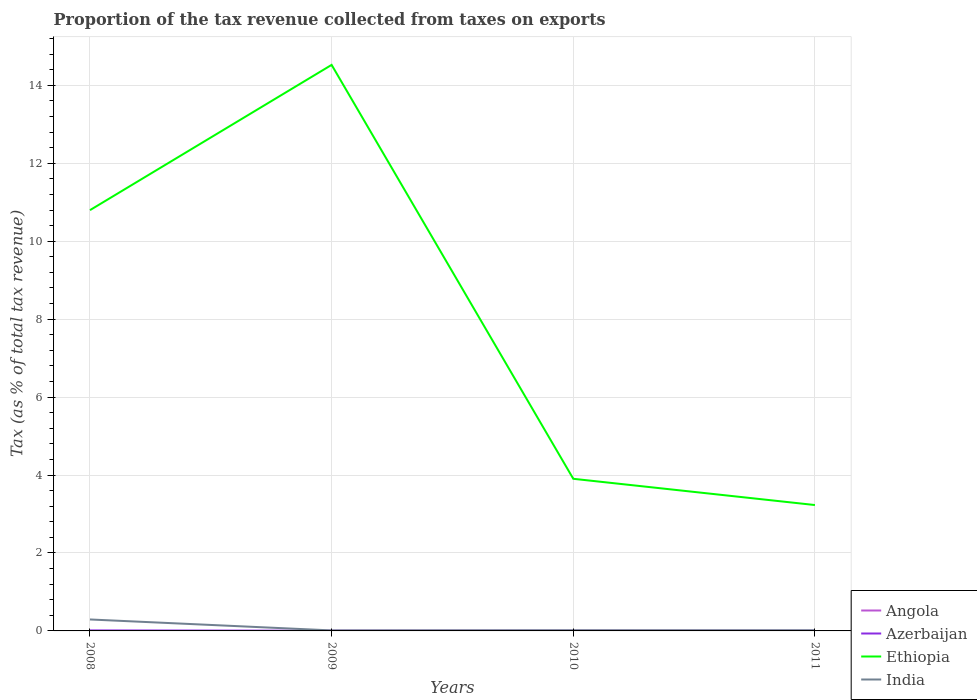Is the number of lines equal to the number of legend labels?
Your response must be concise. Yes. Across all years, what is the maximum proportion of the tax revenue collected in Azerbaijan?
Offer a very short reply. 0. In which year was the proportion of the tax revenue collected in India maximum?
Offer a terse response. 2009. What is the total proportion of the tax revenue collected in Azerbaijan in the graph?
Give a very brief answer. 0.01. What is the difference between the highest and the second highest proportion of the tax revenue collected in Azerbaijan?
Ensure brevity in your answer.  0.01. Is the proportion of the tax revenue collected in India strictly greater than the proportion of the tax revenue collected in Angola over the years?
Provide a short and direct response. No. Does the graph contain grids?
Offer a terse response. Yes. Where does the legend appear in the graph?
Offer a terse response. Bottom right. How many legend labels are there?
Make the answer very short. 4. How are the legend labels stacked?
Provide a short and direct response. Vertical. What is the title of the graph?
Keep it short and to the point. Proportion of the tax revenue collected from taxes on exports. Does "Morocco" appear as one of the legend labels in the graph?
Your answer should be very brief. No. What is the label or title of the X-axis?
Provide a succinct answer. Years. What is the label or title of the Y-axis?
Offer a very short reply. Tax (as % of total tax revenue). What is the Tax (as % of total tax revenue) of Angola in 2008?
Your response must be concise. 0. What is the Tax (as % of total tax revenue) in Azerbaijan in 2008?
Keep it short and to the point. 0.01. What is the Tax (as % of total tax revenue) of Ethiopia in 2008?
Keep it short and to the point. 10.8. What is the Tax (as % of total tax revenue) of India in 2008?
Offer a very short reply. 0.29. What is the Tax (as % of total tax revenue) of Angola in 2009?
Provide a succinct answer. 0. What is the Tax (as % of total tax revenue) in Azerbaijan in 2009?
Keep it short and to the point. 0. What is the Tax (as % of total tax revenue) in Ethiopia in 2009?
Your answer should be compact. 14.53. What is the Tax (as % of total tax revenue) of India in 2009?
Your answer should be very brief. 0.01. What is the Tax (as % of total tax revenue) in Angola in 2010?
Offer a terse response. 0. What is the Tax (as % of total tax revenue) of Azerbaijan in 2010?
Your answer should be compact. 0. What is the Tax (as % of total tax revenue) of Ethiopia in 2010?
Your response must be concise. 3.9. What is the Tax (as % of total tax revenue) of India in 2010?
Your answer should be very brief. 0.02. What is the Tax (as % of total tax revenue) of Angola in 2011?
Provide a succinct answer. 0. What is the Tax (as % of total tax revenue) of Azerbaijan in 2011?
Your response must be concise. 0. What is the Tax (as % of total tax revenue) in Ethiopia in 2011?
Your answer should be compact. 3.23. What is the Tax (as % of total tax revenue) of India in 2011?
Give a very brief answer. 0.02. Across all years, what is the maximum Tax (as % of total tax revenue) of Angola?
Ensure brevity in your answer.  0. Across all years, what is the maximum Tax (as % of total tax revenue) in Azerbaijan?
Ensure brevity in your answer.  0.01. Across all years, what is the maximum Tax (as % of total tax revenue) in Ethiopia?
Make the answer very short. 14.53. Across all years, what is the maximum Tax (as % of total tax revenue) of India?
Your response must be concise. 0.29. Across all years, what is the minimum Tax (as % of total tax revenue) in Angola?
Provide a succinct answer. 0. Across all years, what is the minimum Tax (as % of total tax revenue) in Azerbaijan?
Your answer should be very brief. 0. Across all years, what is the minimum Tax (as % of total tax revenue) of Ethiopia?
Offer a very short reply. 3.23. Across all years, what is the minimum Tax (as % of total tax revenue) of India?
Make the answer very short. 0.01. What is the total Tax (as % of total tax revenue) in Angola in the graph?
Make the answer very short. 0. What is the total Tax (as % of total tax revenue) in Azerbaijan in the graph?
Give a very brief answer. 0.02. What is the total Tax (as % of total tax revenue) of Ethiopia in the graph?
Make the answer very short. 32.46. What is the total Tax (as % of total tax revenue) of India in the graph?
Make the answer very short. 0.34. What is the difference between the Tax (as % of total tax revenue) of Angola in 2008 and that in 2009?
Make the answer very short. -0. What is the difference between the Tax (as % of total tax revenue) of Azerbaijan in 2008 and that in 2009?
Your answer should be very brief. 0.01. What is the difference between the Tax (as % of total tax revenue) in Ethiopia in 2008 and that in 2009?
Provide a short and direct response. -3.73. What is the difference between the Tax (as % of total tax revenue) in India in 2008 and that in 2009?
Provide a succinct answer. 0.28. What is the difference between the Tax (as % of total tax revenue) in Angola in 2008 and that in 2010?
Keep it short and to the point. -0. What is the difference between the Tax (as % of total tax revenue) of Azerbaijan in 2008 and that in 2010?
Give a very brief answer. 0.01. What is the difference between the Tax (as % of total tax revenue) in Ethiopia in 2008 and that in 2010?
Make the answer very short. 6.89. What is the difference between the Tax (as % of total tax revenue) of India in 2008 and that in 2010?
Your answer should be very brief. 0.28. What is the difference between the Tax (as % of total tax revenue) of Angola in 2008 and that in 2011?
Offer a terse response. -0. What is the difference between the Tax (as % of total tax revenue) in Azerbaijan in 2008 and that in 2011?
Offer a very short reply. 0.01. What is the difference between the Tax (as % of total tax revenue) of Ethiopia in 2008 and that in 2011?
Offer a terse response. 7.57. What is the difference between the Tax (as % of total tax revenue) of India in 2008 and that in 2011?
Your answer should be compact. 0.28. What is the difference between the Tax (as % of total tax revenue) of Angola in 2009 and that in 2010?
Your answer should be very brief. -0. What is the difference between the Tax (as % of total tax revenue) of Ethiopia in 2009 and that in 2010?
Provide a succinct answer. 10.62. What is the difference between the Tax (as % of total tax revenue) in India in 2009 and that in 2010?
Make the answer very short. -0. What is the difference between the Tax (as % of total tax revenue) of Azerbaijan in 2009 and that in 2011?
Provide a short and direct response. 0. What is the difference between the Tax (as % of total tax revenue) of Ethiopia in 2009 and that in 2011?
Your answer should be compact. 11.3. What is the difference between the Tax (as % of total tax revenue) of India in 2009 and that in 2011?
Offer a very short reply. -0. What is the difference between the Tax (as % of total tax revenue) of Angola in 2010 and that in 2011?
Keep it short and to the point. 0. What is the difference between the Tax (as % of total tax revenue) in Azerbaijan in 2010 and that in 2011?
Offer a terse response. 0. What is the difference between the Tax (as % of total tax revenue) in Ethiopia in 2010 and that in 2011?
Provide a short and direct response. 0.67. What is the difference between the Tax (as % of total tax revenue) of India in 2010 and that in 2011?
Provide a succinct answer. 0. What is the difference between the Tax (as % of total tax revenue) in Angola in 2008 and the Tax (as % of total tax revenue) in Azerbaijan in 2009?
Offer a very short reply. -0. What is the difference between the Tax (as % of total tax revenue) in Angola in 2008 and the Tax (as % of total tax revenue) in Ethiopia in 2009?
Give a very brief answer. -14.53. What is the difference between the Tax (as % of total tax revenue) in Angola in 2008 and the Tax (as % of total tax revenue) in India in 2009?
Your answer should be very brief. -0.01. What is the difference between the Tax (as % of total tax revenue) of Azerbaijan in 2008 and the Tax (as % of total tax revenue) of Ethiopia in 2009?
Offer a terse response. -14.51. What is the difference between the Tax (as % of total tax revenue) in Azerbaijan in 2008 and the Tax (as % of total tax revenue) in India in 2009?
Make the answer very short. -0. What is the difference between the Tax (as % of total tax revenue) in Ethiopia in 2008 and the Tax (as % of total tax revenue) in India in 2009?
Keep it short and to the point. 10.78. What is the difference between the Tax (as % of total tax revenue) in Angola in 2008 and the Tax (as % of total tax revenue) in Azerbaijan in 2010?
Your response must be concise. -0. What is the difference between the Tax (as % of total tax revenue) in Angola in 2008 and the Tax (as % of total tax revenue) in Ethiopia in 2010?
Ensure brevity in your answer.  -3.9. What is the difference between the Tax (as % of total tax revenue) in Angola in 2008 and the Tax (as % of total tax revenue) in India in 2010?
Your answer should be compact. -0.02. What is the difference between the Tax (as % of total tax revenue) in Azerbaijan in 2008 and the Tax (as % of total tax revenue) in Ethiopia in 2010?
Make the answer very short. -3.89. What is the difference between the Tax (as % of total tax revenue) in Azerbaijan in 2008 and the Tax (as % of total tax revenue) in India in 2010?
Your response must be concise. -0. What is the difference between the Tax (as % of total tax revenue) in Ethiopia in 2008 and the Tax (as % of total tax revenue) in India in 2010?
Your answer should be compact. 10.78. What is the difference between the Tax (as % of total tax revenue) in Angola in 2008 and the Tax (as % of total tax revenue) in Azerbaijan in 2011?
Provide a succinct answer. -0. What is the difference between the Tax (as % of total tax revenue) in Angola in 2008 and the Tax (as % of total tax revenue) in Ethiopia in 2011?
Your answer should be very brief. -3.23. What is the difference between the Tax (as % of total tax revenue) in Angola in 2008 and the Tax (as % of total tax revenue) in India in 2011?
Offer a terse response. -0.02. What is the difference between the Tax (as % of total tax revenue) in Azerbaijan in 2008 and the Tax (as % of total tax revenue) in Ethiopia in 2011?
Offer a terse response. -3.22. What is the difference between the Tax (as % of total tax revenue) in Azerbaijan in 2008 and the Tax (as % of total tax revenue) in India in 2011?
Your answer should be compact. -0. What is the difference between the Tax (as % of total tax revenue) in Ethiopia in 2008 and the Tax (as % of total tax revenue) in India in 2011?
Your answer should be very brief. 10.78. What is the difference between the Tax (as % of total tax revenue) in Angola in 2009 and the Tax (as % of total tax revenue) in Azerbaijan in 2010?
Give a very brief answer. -0. What is the difference between the Tax (as % of total tax revenue) in Angola in 2009 and the Tax (as % of total tax revenue) in Ethiopia in 2010?
Make the answer very short. -3.9. What is the difference between the Tax (as % of total tax revenue) of Angola in 2009 and the Tax (as % of total tax revenue) of India in 2010?
Keep it short and to the point. -0.02. What is the difference between the Tax (as % of total tax revenue) of Azerbaijan in 2009 and the Tax (as % of total tax revenue) of Ethiopia in 2010?
Make the answer very short. -3.9. What is the difference between the Tax (as % of total tax revenue) of Azerbaijan in 2009 and the Tax (as % of total tax revenue) of India in 2010?
Give a very brief answer. -0.01. What is the difference between the Tax (as % of total tax revenue) of Ethiopia in 2009 and the Tax (as % of total tax revenue) of India in 2010?
Keep it short and to the point. 14.51. What is the difference between the Tax (as % of total tax revenue) in Angola in 2009 and the Tax (as % of total tax revenue) in Azerbaijan in 2011?
Provide a succinct answer. -0. What is the difference between the Tax (as % of total tax revenue) in Angola in 2009 and the Tax (as % of total tax revenue) in Ethiopia in 2011?
Provide a short and direct response. -3.23. What is the difference between the Tax (as % of total tax revenue) of Angola in 2009 and the Tax (as % of total tax revenue) of India in 2011?
Provide a succinct answer. -0.02. What is the difference between the Tax (as % of total tax revenue) in Azerbaijan in 2009 and the Tax (as % of total tax revenue) in Ethiopia in 2011?
Your answer should be compact. -3.23. What is the difference between the Tax (as % of total tax revenue) in Azerbaijan in 2009 and the Tax (as % of total tax revenue) in India in 2011?
Your answer should be compact. -0.01. What is the difference between the Tax (as % of total tax revenue) in Ethiopia in 2009 and the Tax (as % of total tax revenue) in India in 2011?
Your answer should be compact. 14.51. What is the difference between the Tax (as % of total tax revenue) in Angola in 2010 and the Tax (as % of total tax revenue) in Azerbaijan in 2011?
Offer a terse response. -0. What is the difference between the Tax (as % of total tax revenue) in Angola in 2010 and the Tax (as % of total tax revenue) in Ethiopia in 2011?
Offer a terse response. -3.23. What is the difference between the Tax (as % of total tax revenue) of Angola in 2010 and the Tax (as % of total tax revenue) of India in 2011?
Your response must be concise. -0.02. What is the difference between the Tax (as % of total tax revenue) in Azerbaijan in 2010 and the Tax (as % of total tax revenue) in Ethiopia in 2011?
Your response must be concise. -3.23. What is the difference between the Tax (as % of total tax revenue) of Azerbaijan in 2010 and the Tax (as % of total tax revenue) of India in 2011?
Your answer should be compact. -0.01. What is the difference between the Tax (as % of total tax revenue) of Ethiopia in 2010 and the Tax (as % of total tax revenue) of India in 2011?
Give a very brief answer. 3.89. What is the average Tax (as % of total tax revenue) of Angola per year?
Provide a succinct answer. 0. What is the average Tax (as % of total tax revenue) of Azerbaijan per year?
Ensure brevity in your answer.  0.01. What is the average Tax (as % of total tax revenue) in Ethiopia per year?
Provide a succinct answer. 8.11. What is the average Tax (as % of total tax revenue) in India per year?
Keep it short and to the point. 0.09. In the year 2008, what is the difference between the Tax (as % of total tax revenue) of Angola and Tax (as % of total tax revenue) of Azerbaijan?
Offer a very short reply. -0.01. In the year 2008, what is the difference between the Tax (as % of total tax revenue) of Angola and Tax (as % of total tax revenue) of Ethiopia?
Provide a succinct answer. -10.8. In the year 2008, what is the difference between the Tax (as % of total tax revenue) in Angola and Tax (as % of total tax revenue) in India?
Your answer should be very brief. -0.29. In the year 2008, what is the difference between the Tax (as % of total tax revenue) of Azerbaijan and Tax (as % of total tax revenue) of Ethiopia?
Ensure brevity in your answer.  -10.79. In the year 2008, what is the difference between the Tax (as % of total tax revenue) of Azerbaijan and Tax (as % of total tax revenue) of India?
Your response must be concise. -0.28. In the year 2008, what is the difference between the Tax (as % of total tax revenue) of Ethiopia and Tax (as % of total tax revenue) of India?
Offer a terse response. 10.5. In the year 2009, what is the difference between the Tax (as % of total tax revenue) of Angola and Tax (as % of total tax revenue) of Azerbaijan?
Offer a terse response. -0. In the year 2009, what is the difference between the Tax (as % of total tax revenue) in Angola and Tax (as % of total tax revenue) in Ethiopia?
Your response must be concise. -14.53. In the year 2009, what is the difference between the Tax (as % of total tax revenue) in Angola and Tax (as % of total tax revenue) in India?
Give a very brief answer. -0.01. In the year 2009, what is the difference between the Tax (as % of total tax revenue) in Azerbaijan and Tax (as % of total tax revenue) in Ethiopia?
Offer a very short reply. -14.52. In the year 2009, what is the difference between the Tax (as % of total tax revenue) of Azerbaijan and Tax (as % of total tax revenue) of India?
Keep it short and to the point. -0.01. In the year 2009, what is the difference between the Tax (as % of total tax revenue) of Ethiopia and Tax (as % of total tax revenue) of India?
Give a very brief answer. 14.51. In the year 2010, what is the difference between the Tax (as % of total tax revenue) in Angola and Tax (as % of total tax revenue) in Azerbaijan?
Your answer should be very brief. -0. In the year 2010, what is the difference between the Tax (as % of total tax revenue) in Angola and Tax (as % of total tax revenue) in Ethiopia?
Keep it short and to the point. -3.9. In the year 2010, what is the difference between the Tax (as % of total tax revenue) in Angola and Tax (as % of total tax revenue) in India?
Offer a very short reply. -0.02. In the year 2010, what is the difference between the Tax (as % of total tax revenue) in Azerbaijan and Tax (as % of total tax revenue) in Ethiopia?
Give a very brief answer. -3.9. In the year 2010, what is the difference between the Tax (as % of total tax revenue) of Azerbaijan and Tax (as % of total tax revenue) of India?
Your answer should be very brief. -0.01. In the year 2010, what is the difference between the Tax (as % of total tax revenue) in Ethiopia and Tax (as % of total tax revenue) in India?
Provide a short and direct response. 3.89. In the year 2011, what is the difference between the Tax (as % of total tax revenue) in Angola and Tax (as % of total tax revenue) in Azerbaijan?
Your answer should be very brief. -0. In the year 2011, what is the difference between the Tax (as % of total tax revenue) of Angola and Tax (as % of total tax revenue) of Ethiopia?
Your answer should be compact. -3.23. In the year 2011, what is the difference between the Tax (as % of total tax revenue) in Angola and Tax (as % of total tax revenue) in India?
Ensure brevity in your answer.  -0.02. In the year 2011, what is the difference between the Tax (as % of total tax revenue) of Azerbaijan and Tax (as % of total tax revenue) of Ethiopia?
Ensure brevity in your answer.  -3.23. In the year 2011, what is the difference between the Tax (as % of total tax revenue) in Azerbaijan and Tax (as % of total tax revenue) in India?
Offer a terse response. -0.01. In the year 2011, what is the difference between the Tax (as % of total tax revenue) of Ethiopia and Tax (as % of total tax revenue) of India?
Give a very brief answer. 3.21. What is the ratio of the Tax (as % of total tax revenue) in Angola in 2008 to that in 2009?
Your answer should be compact. 0.8. What is the ratio of the Tax (as % of total tax revenue) of Azerbaijan in 2008 to that in 2009?
Offer a very short reply. 3.05. What is the ratio of the Tax (as % of total tax revenue) of Ethiopia in 2008 to that in 2009?
Ensure brevity in your answer.  0.74. What is the ratio of the Tax (as % of total tax revenue) of India in 2008 to that in 2009?
Give a very brief answer. 22.66. What is the ratio of the Tax (as % of total tax revenue) in Angola in 2008 to that in 2010?
Your response must be concise. 0.7. What is the ratio of the Tax (as % of total tax revenue) of Azerbaijan in 2008 to that in 2010?
Give a very brief answer. 3.13. What is the ratio of the Tax (as % of total tax revenue) of Ethiopia in 2008 to that in 2010?
Your response must be concise. 2.77. What is the ratio of the Tax (as % of total tax revenue) in India in 2008 to that in 2010?
Your answer should be compact. 17.53. What is the ratio of the Tax (as % of total tax revenue) of Angola in 2008 to that in 2011?
Provide a succinct answer. 0.89. What is the ratio of the Tax (as % of total tax revenue) in Azerbaijan in 2008 to that in 2011?
Make the answer very short. 3.86. What is the ratio of the Tax (as % of total tax revenue) in Ethiopia in 2008 to that in 2011?
Offer a terse response. 3.34. What is the ratio of the Tax (as % of total tax revenue) in India in 2008 to that in 2011?
Provide a short and direct response. 17.53. What is the ratio of the Tax (as % of total tax revenue) in Angola in 2009 to that in 2010?
Provide a short and direct response. 0.87. What is the ratio of the Tax (as % of total tax revenue) in Azerbaijan in 2009 to that in 2010?
Offer a terse response. 1.03. What is the ratio of the Tax (as % of total tax revenue) in Ethiopia in 2009 to that in 2010?
Give a very brief answer. 3.72. What is the ratio of the Tax (as % of total tax revenue) in India in 2009 to that in 2010?
Make the answer very short. 0.77. What is the ratio of the Tax (as % of total tax revenue) in Angola in 2009 to that in 2011?
Keep it short and to the point. 1.11. What is the ratio of the Tax (as % of total tax revenue) in Azerbaijan in 2009 to that in 2011?
Make the answer very short. 1.27. What is the ratio of the Tax (as % of total tax revenue) of Ethiopia in 2009 to that in 2011?
Provide a succinct answer. 4.5. What is the ratio of the Tax (as % of total tax revenue) in India in 2009 to that in 2011?
Make the answer very short. 0.77. What is the ratio of the Tax (as % of total tax revenue) in Angola in 2010 to that in 2011?
Your answer should be compact. 1.27. What is the ratio of the Tax (as % of total tax revenue) in Azerbaijan in 2010 to that in 2011?
Make the answer very short. 1.23. What is the ratio of the Tax (as % of total tax revenue) of Ethiopia in 2010 to that in 2011?
Keep it short and to the point. 1.21. What is the ratio of the Tax (as % of total tax revenue) in India in 2010 to that in 2011?
Offer a very short reply. 1. What is the difference between the highest and the second highest Tax (as % of total tax revenue) in Azerbaijan?
Provide a succinct answer. 0.01. What is the difference between the highest and the second highest Tax (as % of total tax revenue) in Ethiopia?
Provide a succinct answer. 3.73. What is the difference between the highest and the second highest Tax (as % of total tax revenue) of India?
Your response must be concise. 0.28. What is the difference between the highest and the lowest Tax (as % of total tax revenue) in Azerbaijan?
Ensure brevity in your answer.  0.01. What is the difference between the highest and the lowest Tax (as % of total tax revenue) in Ethiopia?
Provide a short and direct response. 11.3. What is the difference between the highest and the lowest Tax (as % of total tax revenue) in India?
Provide a short and direct response. 0.28. 